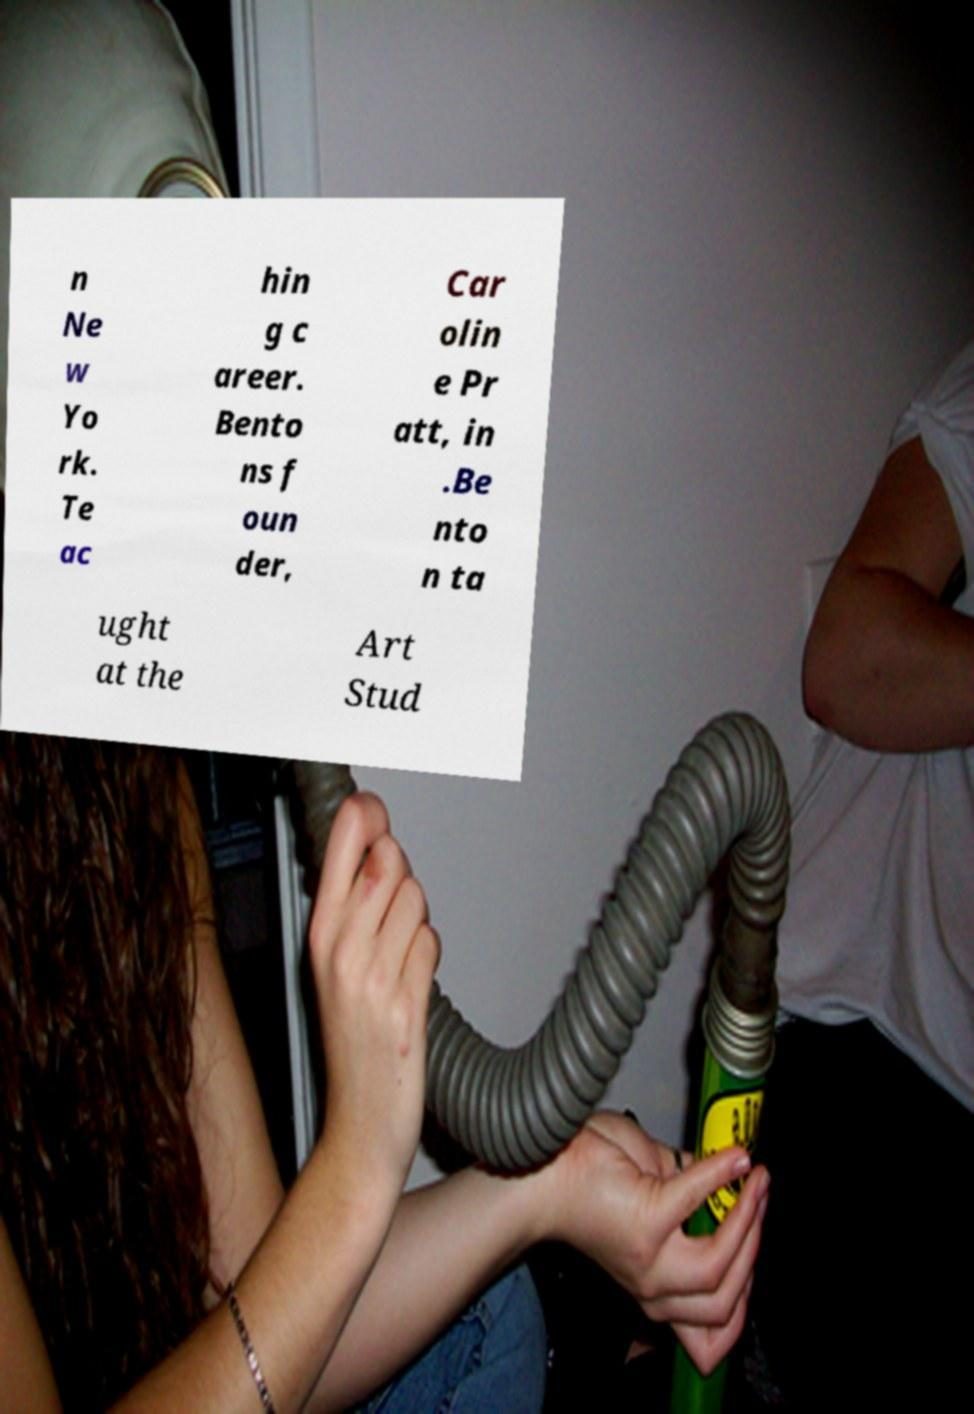Please read and relay the text visible in this image. What does it say? n Ne w Yo rk. Te ac hin g c areer. Bento ns f oun der, Car olin e Pr att, in .Be nto n ta ught at the Art Stud 